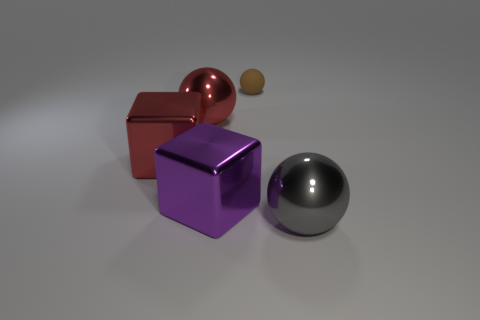Add 2 small brown rubber cylinders. How many objects exist? 7 Subtract all spheres. How many objects are left? 2 Subtract all metal objects. Subtract all small brown rubber things. How many objects are left? 0 Add 5 large gray metallic spheres. How many large gray metallic spheres are left? 6 Add 2 big purple blocks. How many big purple blocks exist? 3 Subtract 0 cyan cylinders. How many objects are left? 5 